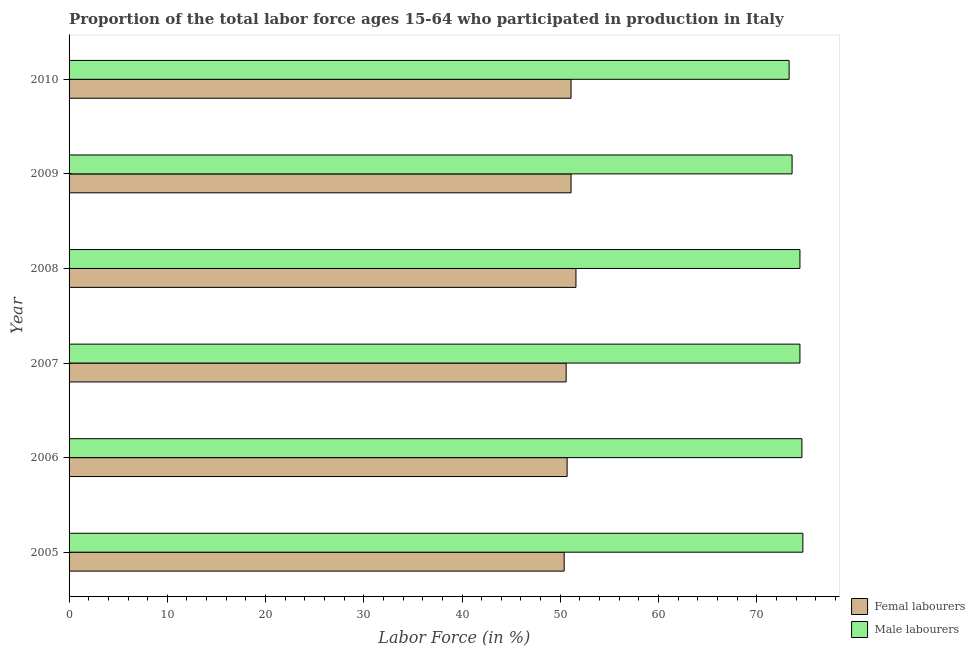How many different coloured bars are there?
Your answer should be compact. 2. How many groups of bars are there?
Give a very brief answer. 6. Are the number of bars per tick equal to the number of legend labels?
Keep it short and to the point. Yes. How many bars are there on the 1st tick from the bottom?
Make the answer very short. 2. What is the label of the 1st group of bars from the top?
Your answer should be compact. 2010. What is the percentage of female labor force in 2010?
Your response must be concise. 51.1. Across all years, what is the maximum percentage of female labor force?
Ensure brevity in your answer.  51.6. Across all years, what is the minimum percentage of male labour force?
Make the answer very short. 73.3. In which year was the percentage of female labor force minimum?
Offer a very short reply. 2005. What is the total percentage of female labor force in the graph?
Provide a succinct answer. 305.5. What is the difference between the percentage of female labor force in 2009 and the percentage of male labour force in 2006?
Offer a very short reply. -23.5. What is the average percentage of male labour force per year?
Your answer should be very brief. 74.17. In how many years, is the percentage of male labour force greater than 46 %?
Make the answer very short. 6. Is the percentage of male labour force in 2006 less than that in 2007?
Make the answer very short. No. Is the difference between the percentage of male labour force in 2005 and 2008 greater than the difference between the percentage of female labor force in 2005 and 2008?
Keep it short and to the point. Yes. What is the difference between the highest and the lowest percentage of male labour force?
Your answer should be very brief. 1.4. In how many years, is the percentage of female labor force greater than the average percentage of female labor force taken over all years?
Offer a very short reply. 3. What does the 1st bar from the top in 2009 represents?
Offer a very short reply. Male labourers. What does the 2nd bar from the bottom in 2009 represents?
Keep it short and to the point. Male labourers. How many bars are there?
Offer a very short reply. 12. How many years are there in the graph?
Provide a short and direct response. 6. What is the difference between two consecutive major ticks on the X-axis?
Offer a terse response. 10. Are the values on the major ticks of X-axis written in scientific E-notation?
Offer a terse response. No. Does the graph contain any zero values?
Provide a succinct answer. No. Does the graph contain grids?
Ensure brevity in your answer.  No. How many legend labels are there?
Your answer should be compact. 2. How are the legend labels stacked?
Make the answer very short. Vertical. What is the title of the graph?
Offer a terse response. Proportion of the total labor force ages 15-64 who participated in production in Italy. What is the label or title of the X-axis?
Ensure brevity in your answer.  Labor Force (in %). What is the label or title of the Y-axis?
Ensure brevity in your answer.  Year. What is the Labor Force (in %) in Femal labourers in 2005?
Ensure brevity in your answer.  50.4. What is the Labor Force (in %) of Male labourers in 2005?
Your answer should be very brief. 74.7. What is the Labor Force (in %) of Femal labourers in 2006?
Provide a short and direct response. 50.7. What is the Labor Force (in %) of Male labourers in 2006?
Your response must be concise. 74.6. What is the Labor Force (in %) in Femal labourers in 2007?
Your answer should be compact. 50.6. What is the Labor Force (in %) in Male labourers in 2007?
Offer a terse response. 74.4. What is the Labor Force (in %) in Femal labourers in 2008?
Your answer should be very brief. 51.6. What is the Labor Force (in %) of Male labourers in 2008?
Your answer should be compact. 74.4. What is the Labor Force (in %) in Femal labourers in 2009?
Offer a very short reply. 51.1. What is the Labor Force (in %) of Male labourers in 2009?
Your response must be concise. 73.6. What is the Labor Force (in %) of Femal labourers in 2010?
Provide a short and direct response. 51.1. What is the Labor Force (in %) in Male labourers in 2010?
Keep it short and to the point. 73.3. Across all years, what is the maximum Labor Force (in %) of Femal labourers?
Make the answer very short. 51.6. Across all years, what is the maximum Labor Force (in %) of Male labourers?
Your answer should be compact. 74.7. Across all years, what is the minimum Labor Force (in %) of Femal labourers?
Ensure brevity in your answer.  50.4. Across all years, what is the minimum Labor Force (in %) in Male labourers?
Keep it short and to the point. 73.3. What is the total Labor Force (in %) of Femal labourers in the graph?
Provide a succinct answer. 305.5. What is the total Labor Force (in %) of Male labourers in the graph?
Your response must be concise. 445. What is the difference between the Labor Force (in %) in Femal labourers in 2005 and that in 2006?
Keep it short and to the point. -0.3. What is the difference between the Labor Force (in %) of Male labourers in 2005 and that in 2006?
Provide a succinct answer. 0.1. What is the difference between the Labor Force (in %) of Femal labourers in 2005 and that in 2009?
Your response must be concise. -0.7. What is the difference between the Labor Force (in %) of Male labourers in 2005 and that in 2009?
Give a very brief answer. 1.1. What is the difference between the Labor Force (in %) in Male labourers in 2005 and that in 2010?
Provide a short and direct response. 1.4. What is the difference between the Labor Force (in %) in Femal labourers in 2006 and that in 2008?
Keep it short and to the point. -0.9. What is the difference between the Labor Force (in %) of Femal labourers in 2006 and that in 2009?
Provide a succinct answer. -0.4. What is the difference between the Labor Force (in %) in Male labourers in 2006 and that in 2009?
Your answer should be very brief. 1. What is the difference between the Labor Force (in %) in Male labourers in 2007 and that in 2009?
Provide a succinct answer. 0.8. What is the difference between the Labor Force (in %) in Femal labourers in 2007 and that in 2010?
Make the answer very short. -0.5. What is the difference between the Labor Force (in %) of Male labourers in 2007 and that in 2010?
Ensure brevity in your answer.  1.1. What is the difference between the Labor Force (in %) in Femal labourers in 2009 and that in 2010?
Provide a succinct answer. 0. What is the difference between the Labor Force (in %) of Femal labourers in 2005 and the Labor Force (in %) of Male labourers in 2006?
Make the answer very short. -24.2. What is the difference between the Labor Force (in %) in Femal labourers in 2005 and the Labor Force (in %) in Male labourers in 2007?
Keep it short and to the point. -24. What is the difference between the Labor Force (in %) in Femal labourers in 2005 and the Labor Force (in %) in Male labourers in 2008?
Keep it short and to the point. -24. What is the difference between the Labor Force (in %) of Femal labourers in 2005 and the Labor Force (in %) of Male labourers in 2009?
Ensure brevity in your answer.  -23.2. What is the difference between the Labor Force (in %) of Femal labourers in 2005 and the Labor Force (in %) of Male labourers in 2010?
Offer a very short reply. -22.9. What is the difference between the Labor Force (in %) of Femal labourers in 2006 and the Labor Force (in %) of Male labourers in 2007?
Your answer should be very brief. -23.7. What is the difference between the Labor Force (in %) of Femal labourers in 2006 and the Labor Force (in %) of Male labourers in 2008?
Make the answer very short. -23.7. What is the difference between the Labor Force (in %) in Femal labourers in 2006 and the Labor Force (in %) in Male labourers in 2009?
Ensure brevity in your answer.  -22.9. What is the difference between the Labor Force (in %) of Femal labourers in 2006 and the Labor Force (in %) of Male labourers in 2010?
Your answer should be compact. -22.6. What is the difference between the Labor Force (in %) in Femal labourers in 2007 and the Labor Force (in %) in Male labourers in 2008?
Provide a succinct answer. -23.8. What is the difference between the Labor Force (in %) in Femal labourers in 2007 and the Labor Force (in %) in Male labourers in 2010?
Provide a succinct answer. -22.7. What is the difference between the Labor Force (in %) in Femal labourers in 2008 and the Labor Force (in %) in Male labourers in 2009?
Provide a succinct answer. -22. What is the difference between the Labor Force (in %) of Femal labourers in 2008 and the Labor Force (in %) of Male labourers in 2010?
Your response must be concise. -21.7. What is the difference between the Labor Force (in %) of Femal labourers in 2009 and the Labor Force (in %) of Male labourers in 2010?
Keep it short and to the point. -22.2. What is the average Labor Force (in %) of Femal labourers per year?
Your answer should be very brief. 50.92. What is the average Labor Force (in %) in Male labourers per year?
Offer a terse response. 74.17. In the year 2005, what is the difference between the Labor Force (in %) of Femal labourers and Labor Force (in %) of Male labourers?
Ensure brevity in your answer.  -24.3. In the year 2006, what is the difference between the Labor Force (in %) in Femal labourers and Labor Force (in %) in Male labourers?
Your answer should be compact. -23.9. In the year 2007, what is the difference between the Labor Force (in %) in Femal labourers and Labor Force (in %) in Male labourers?
Your answer should be very brief. -23.8. In the year 2008, what is the difference between the Labor Force (in %) in Femal labourers and Labor Force (in %) in Male labourers?
Give a very brief answer. -22.8. In the year 2009, what is the difference between the Labor Force (in %) of Femal labourers and Labor Force (in %) of Male labourers?
Offer a terse response. -22.5. In the year 2010, what is the difference between the Labor Force (in %) of Femal labourers and Labor Force (in %) of Male labourers?
Provide a short and direct response. -22.2. What is the ratio of the Labor Force (in %) in Femal labourers in 2005 to that in 2006?
Make the answer very short. 0.99. What is the ratio of the Labor Force (in %) of Male labourers in 2005 to that in 2006?
Offer a very short reply. 1. What is the ratio of the Labor Force (in %) of Femal labourers in 2005 to that in 2008?
Provide a short and direct response. 0.98. What is the ratio of the Labor Force (in %) in Male labourers in 2005 to that in 2008?
Ensure brevity in your answer.  1. What is the ratio of the Labor Force (in %) of Femal labourers in 2005 to that in 2009?
Your answer should be very brief. 0.99. What is the ratio of the Labor Force (in %) of Male labourers in 2005 to that in 2009?
Your answer should be compact. 1.01. What is the ratio of the Labor Force (in %) in Femal labourers in 2005 to that in 2010?
Provide a short and direct response. 0.99. What is the ratio of the Labor Force (in %) of Male labourers in 2005 to that in 2010?
Keep it short and to the point. 1.02. What is the ratio of the Labor Force (in %) of Male labourers in 2006 to that in 2007?
Provide a succinct answer. 1. What is the ratio of the Labor Force (in %) of Femal labourers in 2006 to that in 2008?
Ensure brevity in your answer.  0.98. What is the ratio of the Labor Force (in %) of Male labourers in 2006 to that in 2008?
Offer a very short reply. 1. What is the ratio of the Labor Force (in %) in Male labourers in 2006 to that in 2009?
Make the answer very short. 1.01. What is the ratio of the Labor Force (in %) of Male labourers in 2006 to that in 2010?
Provide a succinct answer. 1.02. What is the ratio of the Labor Force (in %) of Femal labourers in 2007 to that in 2008?
Offer a terse response. 0.98. What is the ratio of the Labor Force (in %) in Male labourers in 2007 to that in 2008?
Keep it short and to the point. 1. What is the ratio of the Labor Force (in %) in Femal labourers in 2007 to that in 2009?
Keep it short and to the point. 0.99. What is the ratio of the Labor Force (in %) of Male labourers in 2007 to that in 2009?
Give a very brief answer. 1.01. What is the ratio of the Labor Force (in %) in Femal labourers in 2007 to that in 2010?
Your response must be concise. 0.99. What is the ratio of the Labor Force (in %) of Male labourers in 2007 to that in 2010?
Your answer should be very brief. 1.01. What is the ratio of the Labor Force (in %) in Femal labourers in 2008 to that in 2009?
Your response must be concise. 1.01. What is the ratio of the Labor Force (in %) in Male labourers in 2008 to that in 2009?
Your answer should be compact. 1.01. What is the ratio of the Labor Force (in %) of Femal labourers in 2008 to that in 2010?
Your response must be concise. 1.01. What is the ratio of the Labor Force (in %) of Male labourers in 2008 to that in 2010?
Your answer should be compact. 1.01. What is the ratio of the Labor Force (in %) of Male labourers in 2009 to that in 2010?
Make the answer very short. 1. What is the difference between the highest and the second highest Labor Force (in %) of Femal labourers?
Your answer should be very brief. 0.5. 